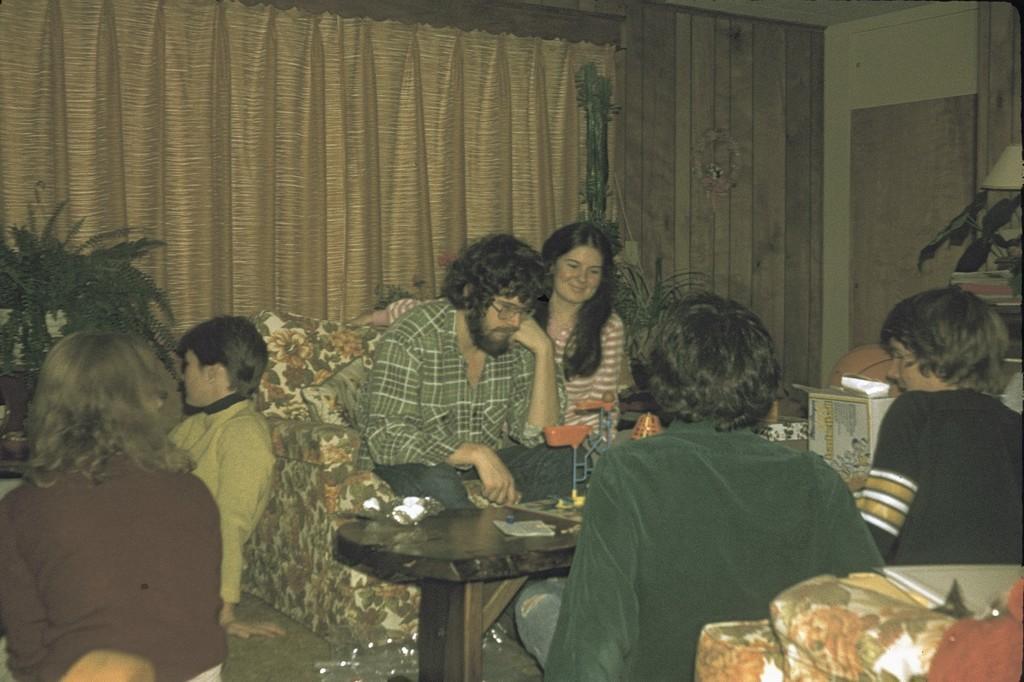In one or two sentences, can you explain what this image depicts? This picture is of inside the room. On the right there are two persons sitting. In the center there is a woman and a man sitting on a couch. On the left there is a woman and a person sitting on the ground. There is a table on the top of which a stand and a book is placed. In the background we can see the curtain, house plant, a lamp and a wall. 